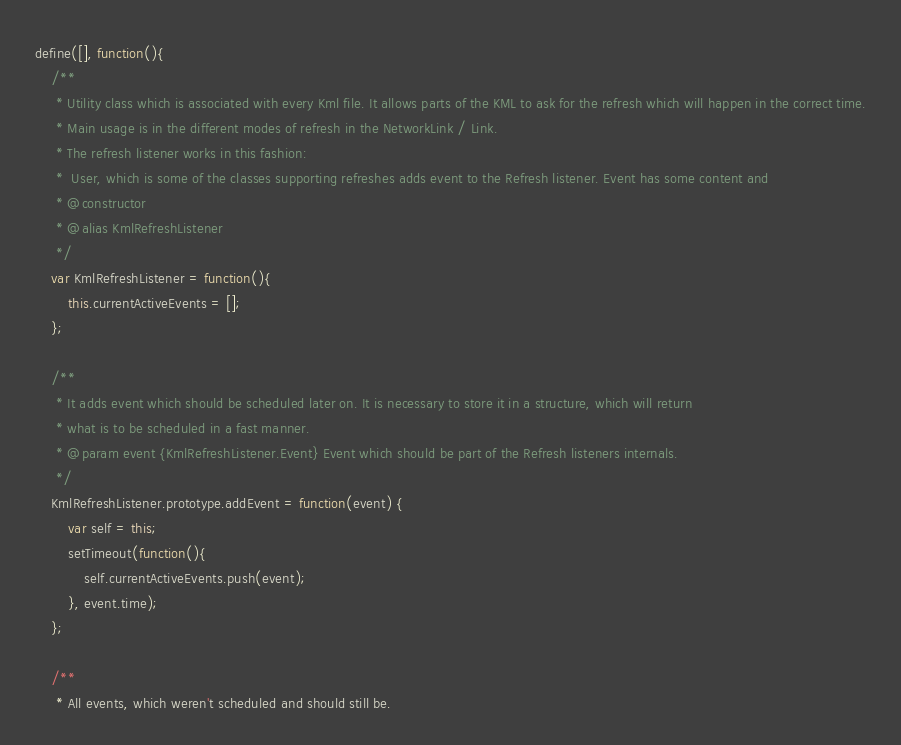Convert code to text. <code><loc_0><loc_0><loc_500><loc_500><_JavaScript_>define([], function(){
	/**
	 * Utility class which is associated with every Kml file. It allows parts of the KML to ask for the refresh which will happen in the correct time.
	 * Main usage is in the different modes of refresh in the NetworkLink / Link.
	 * The refresh listener works in this fashion:
	 * 	User, which is some of the classes supporting refreshes adds event to the Refresh listener. Event has some content and
	 * @constructor
	 * @alias KmlRefreshListener
	 */
	var KmlRefreshListener = function(){
		this.currentActiveEvents = [];
	};

	/**
	 * It adds event which should be scheduled later on. It is necessary to store it in a structure, which will return
	 * what is to be scheduled in a fast manner.
	 * @param event {KmlRefreshListener.Event} Event which should be part of the Refresh listeners internals.
	 */
	KmlRefreshListener.prototype.addEvent = function(event) {
		var self = this;
		setTimeout(function(){
			self.currentActiveEvents.push(event);
		}, event.time);
	};

	/**
	 * All events, which weren't scheduled and should still be.</code> 